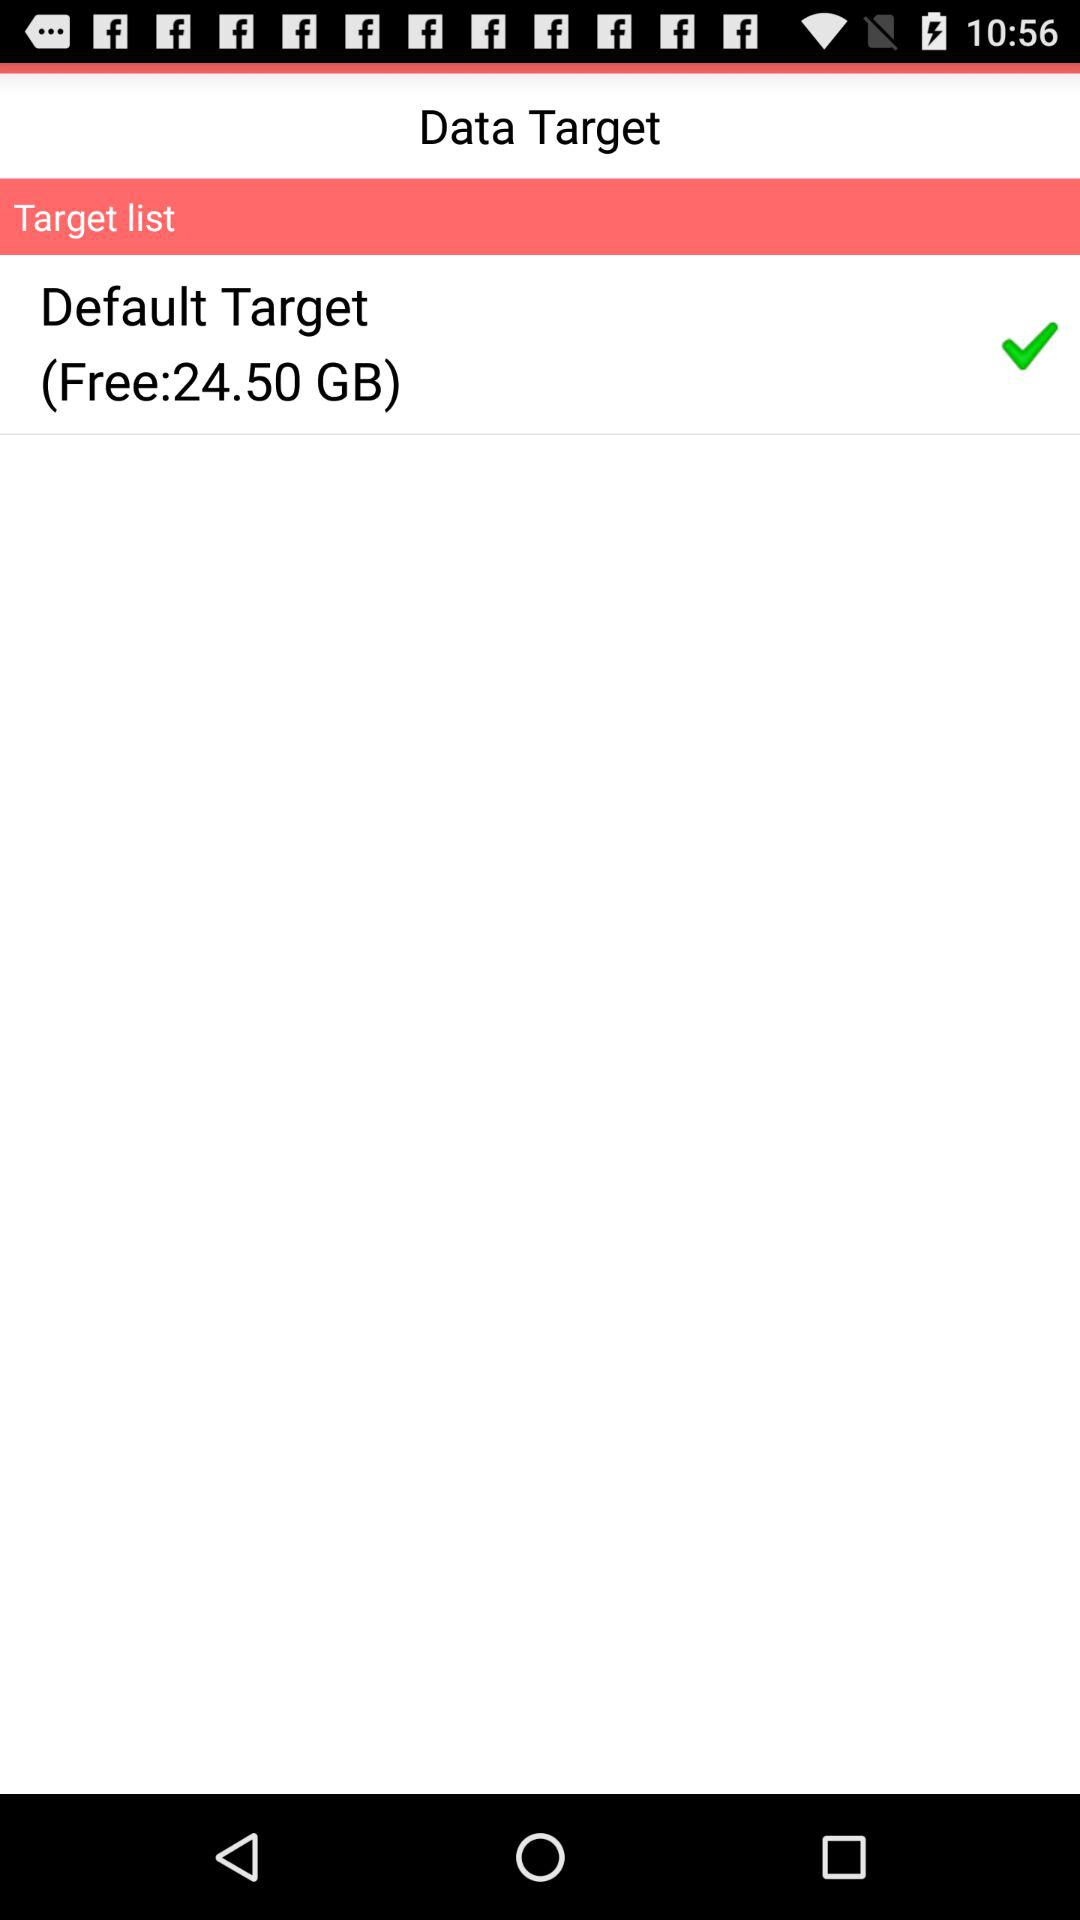What is the checked option? The checked option is "Default Target". 